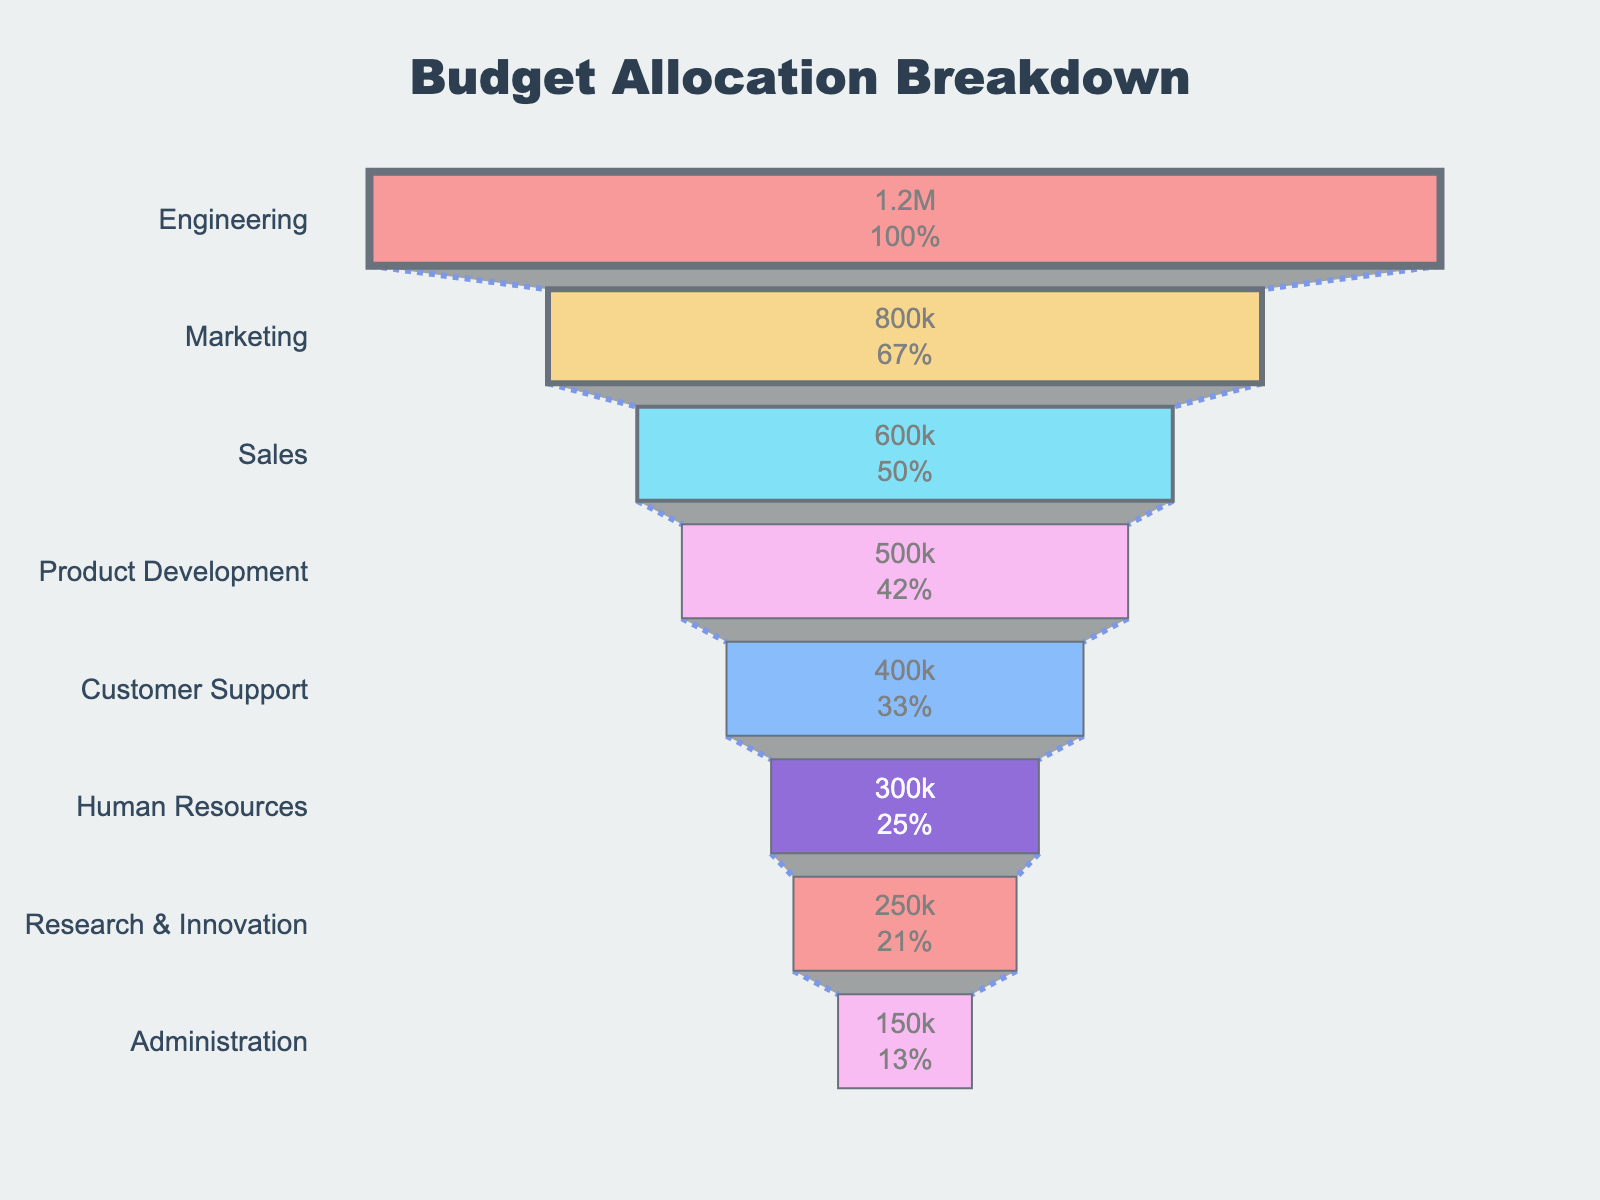What is the title of the figure? The title is prominently displayed at the top of the figure. It provides an overview of what the visual represents.
Answer: Budget Allocation Breakdown Which department has the largest budget allocation? By observing the funnel chart from top to bottom, the top segment represents the department with the largest budget allocation.
Answer: Engineering What is the budget allocation for Research & Innovation? The chart shows the exact budget allocation for each department within their respective segments.
Answer: $250,000 How much more budget is allocated to Marketing compared to Sales? Identify the budget allocations for both Marketing ($800,000) and Sales ($600,000) and calculate the difference. 800,000 - 600,000 = 200,000
Answer: $200,000 What percentage of the total initial budget is allocated to Product Development? The chart provides percentage values of the initial total budget for each segment. Locate the percentage and check against Product Development.
Answer: 12.50% Which department has the smallest budget allocation, and what is it? The smallest segment at the bottom of the funnel represents the department with the smallest budget.
Answer: Administration, $150,000 Is the budget allocation for Customer Support greater or less than Human Resources? Compare the two respective segments on the chart. Customer Support is above Human Resources, indicating a larger budget.
Answer: Greater What is the total budget allocation for Sales and Human Resources combined? Sum the budget allocations for Sales ($600,000) and Human Resources ($300,000). 600,000 + 300,000 = 900,000
Answer: $900,000 How does the budget allocation for Product Development compare to Customer Support? Compare the heights of the segments for Product Development ($500,000) and Customer Support ($400,000) in the funnel chart.
Answer: Product Development has a higher budget allocation If the total initial budget is $4,500,000, what percentage of the budget is allocated to Engineering? Divide the Engineering budget ($1,200,000) by the total budget ($4,500,000) and multiply by 100 to get the percentage. (1,200,000 / 4,500,000) * 100 = 26.67%
Answer: 26.67% 